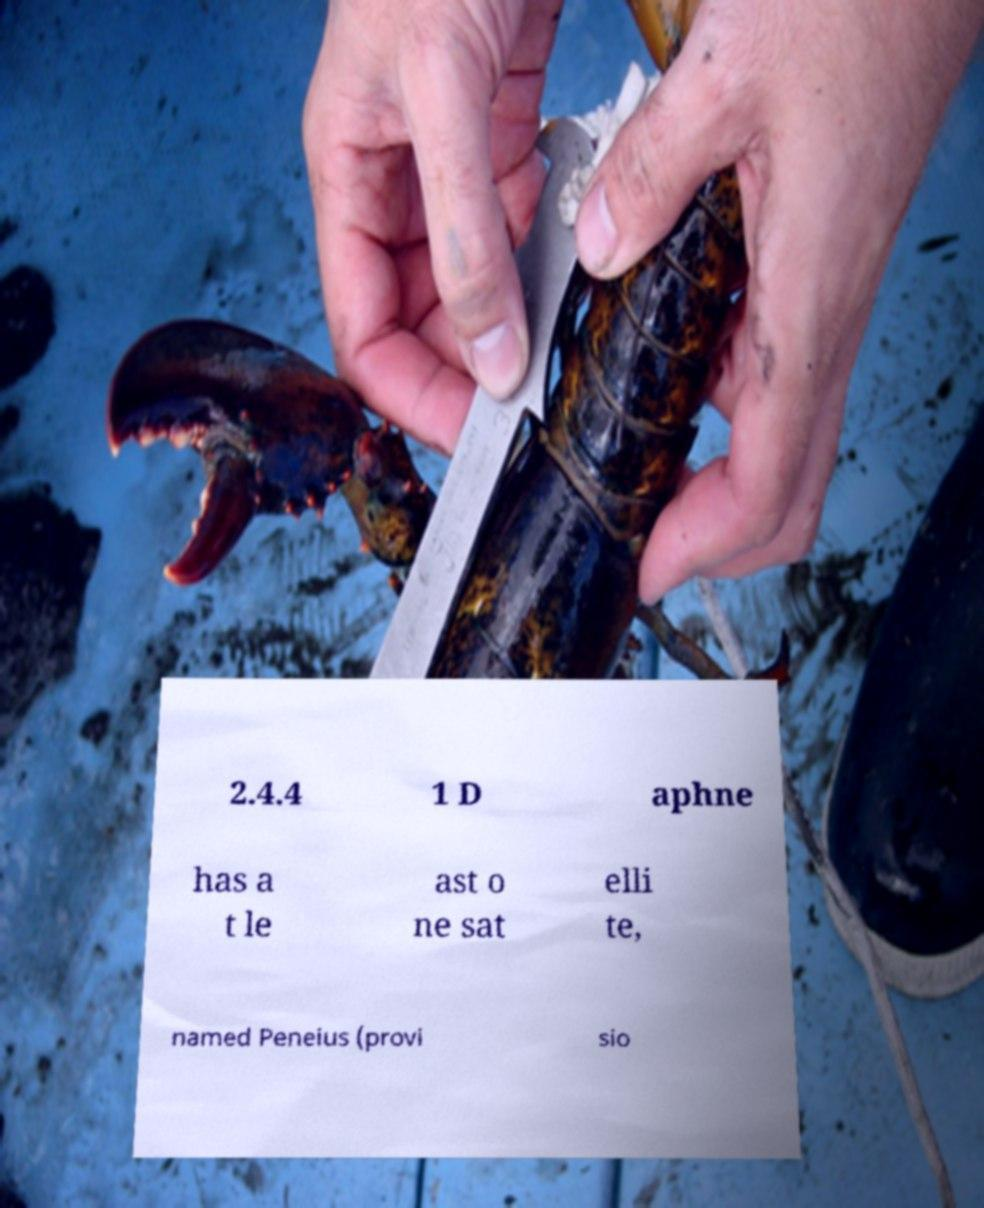For documentation purposes, I need the text within this image transcribed. Could you provide that? 2.4.4 1 D aphne has a t le ast o ne sat elli te, named Peneius (provi sio 